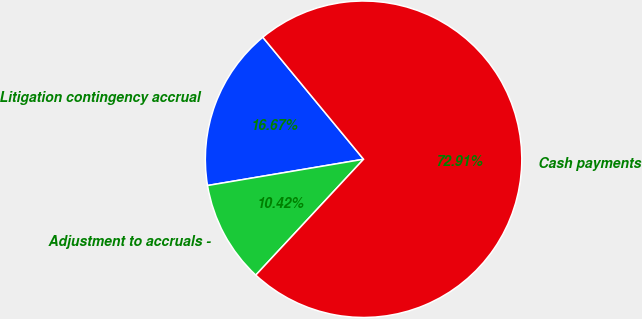Convert chart to OTSL. <chart><loc_0><loc_0><loc_500><loc_500><pie_chart><fcel>Litigation contingency accrual<fcel>Adjustment to accruals -<fcel>Cash payments<nl><fcel>16.67%<fcel>10.42%<fcel>72.92%<nl></chart> 